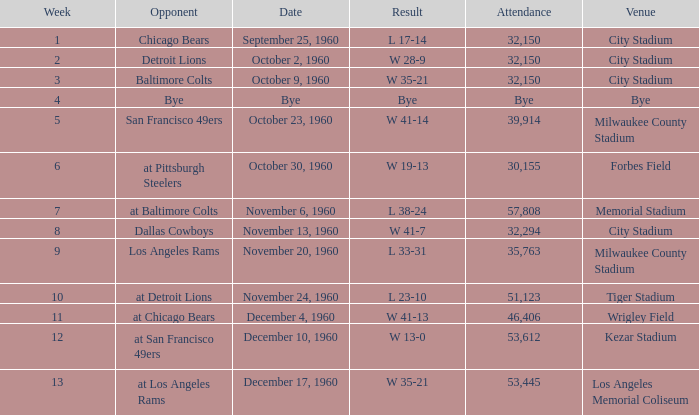What number of people went to the tiger stadium L 23-10. Write the full table. {'header': ['Week', 'Opponent', 'Date', 'Result', 'Attendance', 'Venue'], 'rows': [['1', 'Chicago Bears', 'September 25, 1960', 'L 17-14', '32,150', 'City Stadium'], ['2', 'Detroit Lions', 'October 2, 1960', 'W 28-9', '32,150', 'City Stadium'], ['3', 'Baltimore Colts', 'October 9, 1960', 'W 35-21', '32,150', 'City Stadium'], ['4', 'Bye', 'Bye', 'Bye', 'Bye', 'Bye'], ['5', 'San Francisco 49ers', 'October 23, 1960', 'W 41-14', '39,914', 'Milwaukee County Stadium'], ['6', 'at Pittsburgh Steelers', 'October 30, 1960', 'W 19-13', '30,155', 'Forbes Field'], ['7', 'at Baltimore Colts', 'November 6, 1960', 'L 38-24', '57,808', 'Memorial Stadium'], ['8', 'Dallas Cowboys', 'November 13, 1960', 'W 41-7', '32,294', 'City Stadium'], ['9', 'Los Angeles Rams', 'November 20, 1960', 'L 33-31', '35,763', 'Milwaukee County Stadium'], ['10', 'at Detroit Lions', 'November 24, 1960', 'L 23-10', '51,123', 'Tiger Stadium'], ['11', 'at Chicago Bears', 'December 4, 1960', 'W 41-13', '46,406', 'Wrigley Field'], ['12', 'at San Francisco 49ers', 'December 10, 1960', 'W 13-0', '53,612', 'Kezar Stadium'], ['13', 'at Los Angeles Rams', 'December 17, 1960', 'W 35-21', '53,445', 'Los Angeles Memorial Coliseum']]} 